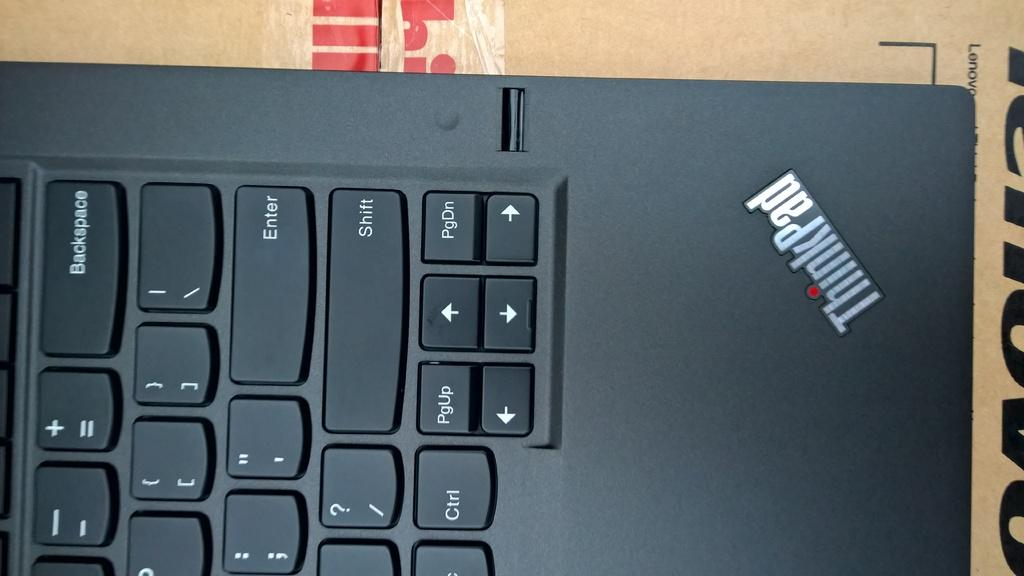Provide a one-sentence caption for the provided image. A keyboard has a ThinkPad logo in the corner and sits on top of cardboard. 